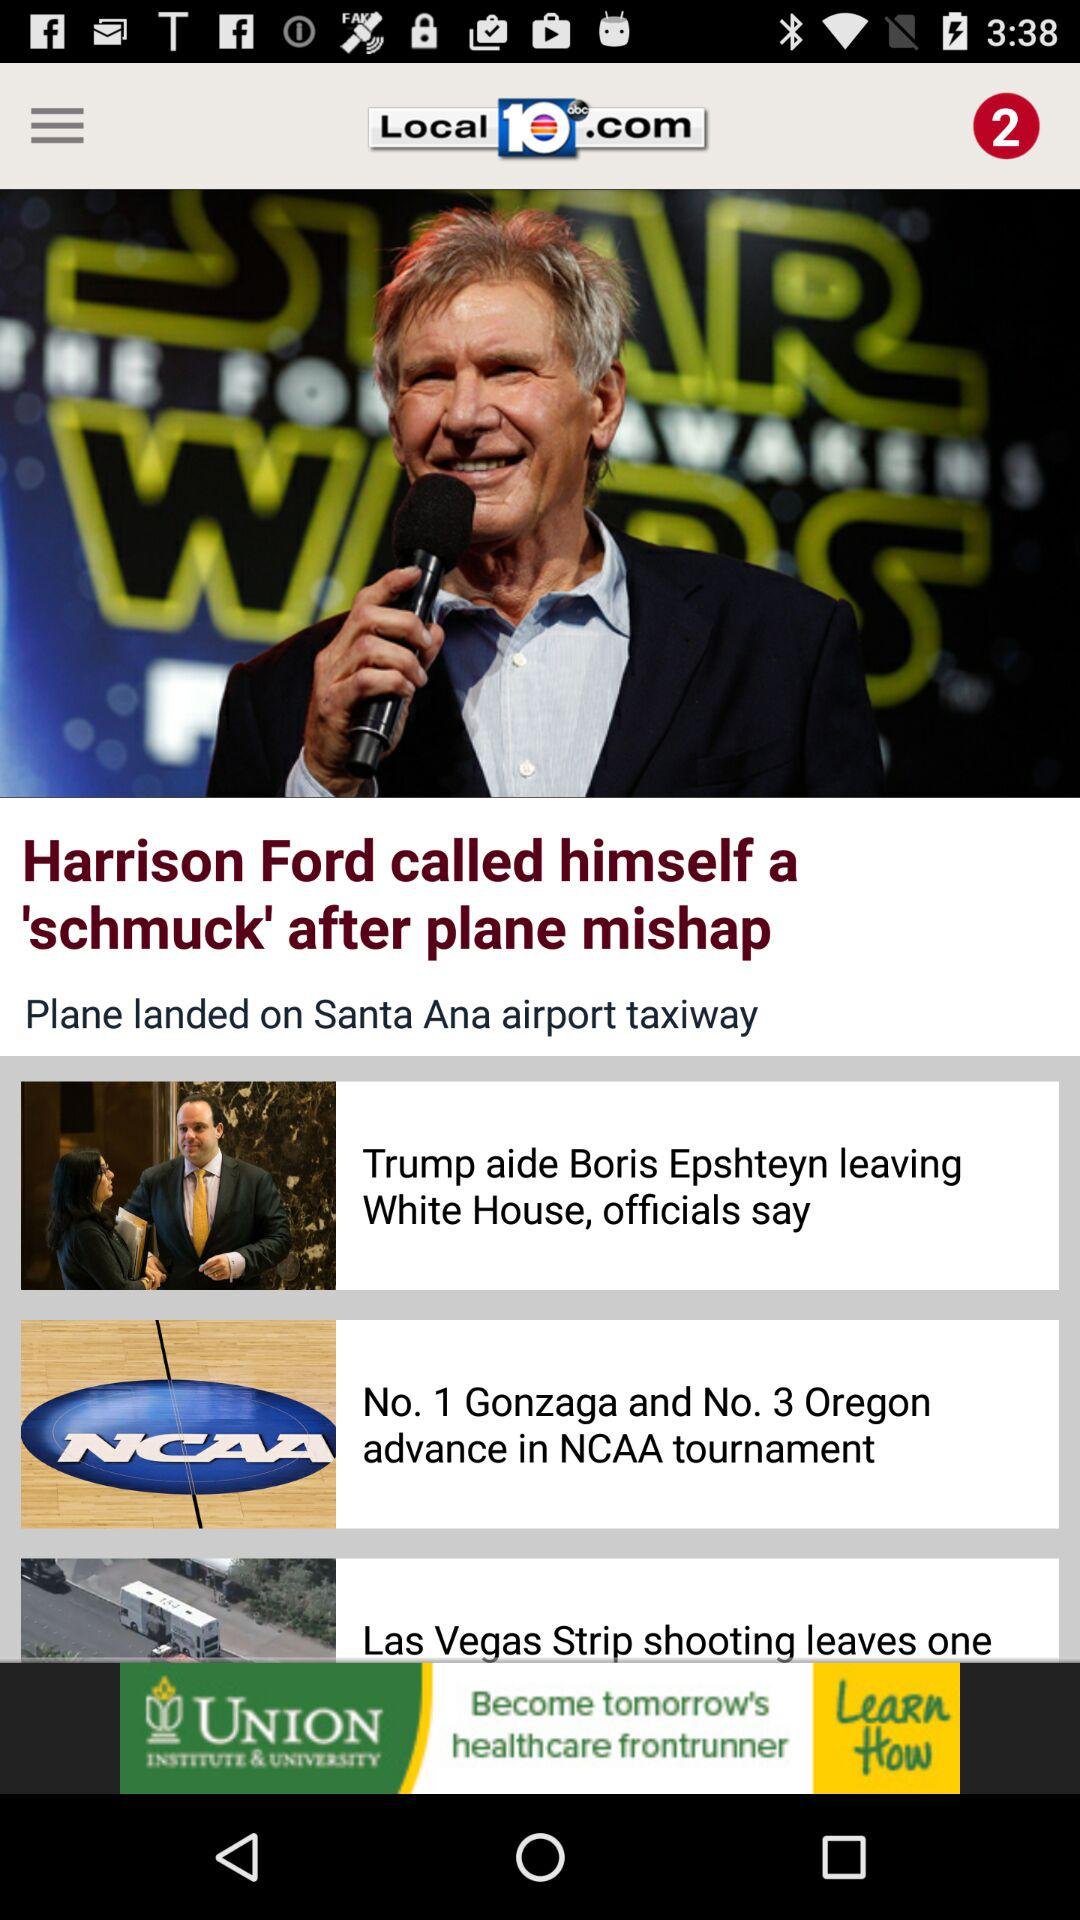At what airport has the plane landed? The plane has landed at Santa Ana Airport. 